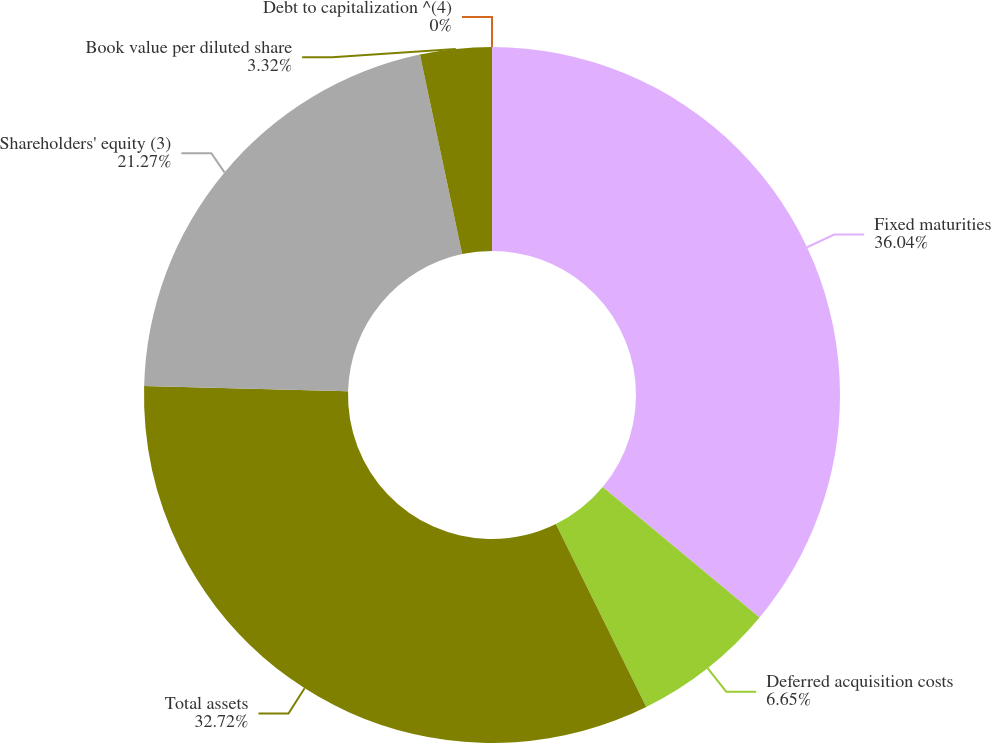<chart> <loc_0><loc_0><loc_500><loc_500><pie_chart><fcel>Fixed maturities<fcel>Deferred acquisition costs<fcel>Total assets<fcel>Shareholders' equity (3)<fcel>Book value per diluted share<fcel>Debt to capitalization ^(4)<nl><fcel>36.04%<fcel>6.65%<fcel>32.72%<fcel>21.27%<fcel>3.32%<fcel>0.0%<nl></chart> 